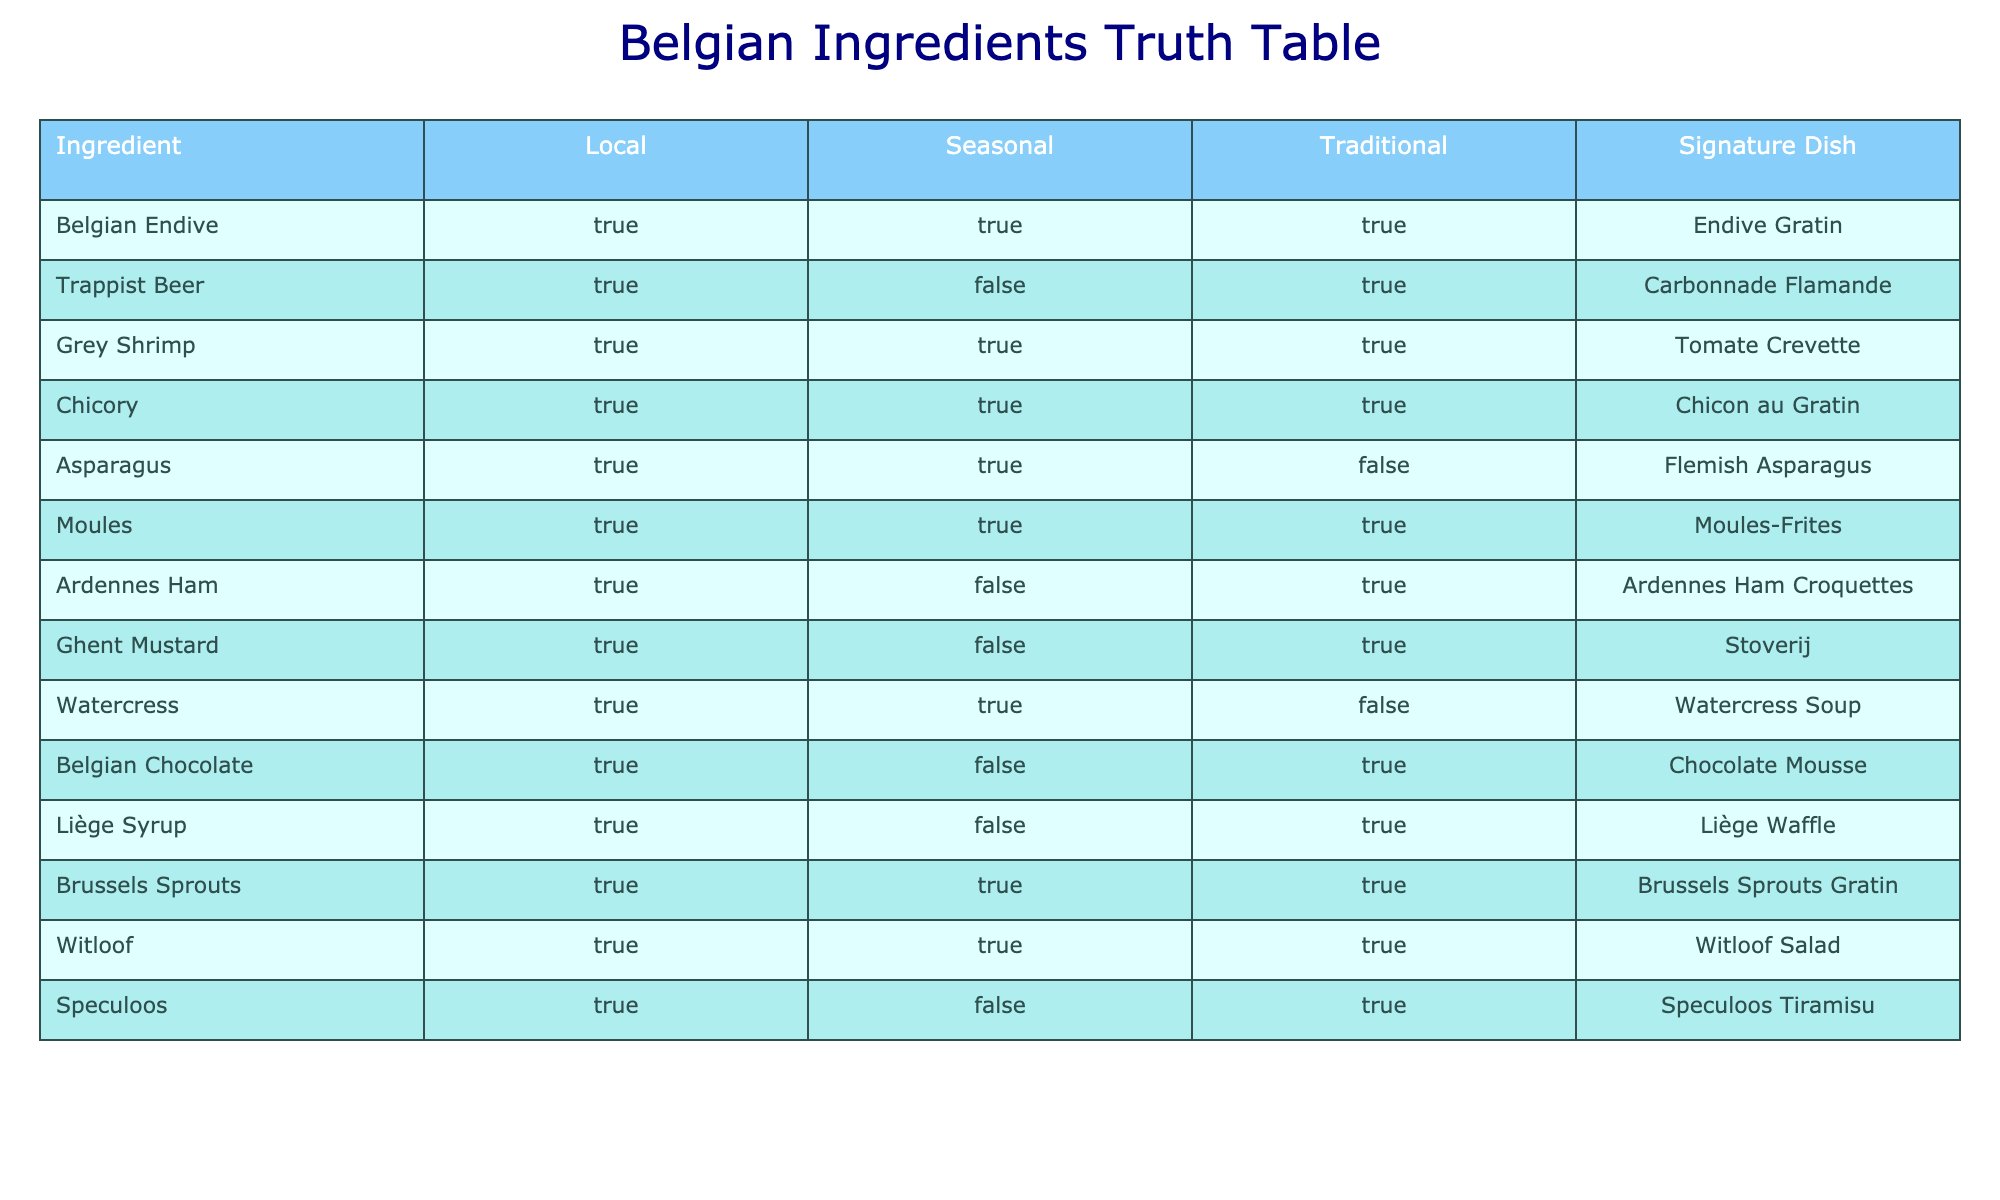What is the signature dish made from Belgian Endive? The table shows that the signature dish corresponding to Belgian Endive is "Endive Gratin."
Answer: Endive Gratin Which ingredient is used in the dish Carbonnade Flamande? The dish Carbonnade Flamande is associated with the ingredient "Trappist Beer" as per the table.
Answer: Trappist Beer How many signature dishes use seasonal ingredients? By examining the table, the signature dishes that use seasonal ingredients are "Endive Gratin," "Grey Shrimp," "Chicory," "Asparagus," "Moules-Frites," "Brussels Sprouts Gratin," and "Witloof Salad." Thus, there are 7 dishes in total.
Answer: 7 Is Ardennes Ham a traditional ingredient? According to the table, Ardennes Ham is marked as a traditional ingredient, as it corresponds to the "Traditional" column being true for this ingredient.
Answer: Yes Which dish is made with Grey Shrimp? The signature dish made with Grey Shrimp, based on the table, is "Tomate Crevette."
Answer: Tomate Crevette What is the sum of signature dishes that are both local and traditional? The table lists the signature dishes that are both local and traditional as "Endive Gratin," "Grey Shrimp," "Chicory," "Moules-Frites," "Brussels Sprouts Gratin," and "Witloof Salad." This totals 6 signature dishes.
Answer: 6 Are there any ingredients that are both local and seasonal but not traditional? The table indicates that there are two such ingredients: "Watercress" and "Asparagus." Therefore, the answer is yes.
Answer: Yes What is the only signature dish made with Ghent Mustard? The table states that the signature dish associated with Ghent Mustard is "Stoverij."
Answer: Stoverij Which ingredient has the least association with being traditional based on the table? The ingredient with the least association with tradition is "Asparagus," which is marked as false under the "Traditional" column.
Answer: Asparagus 